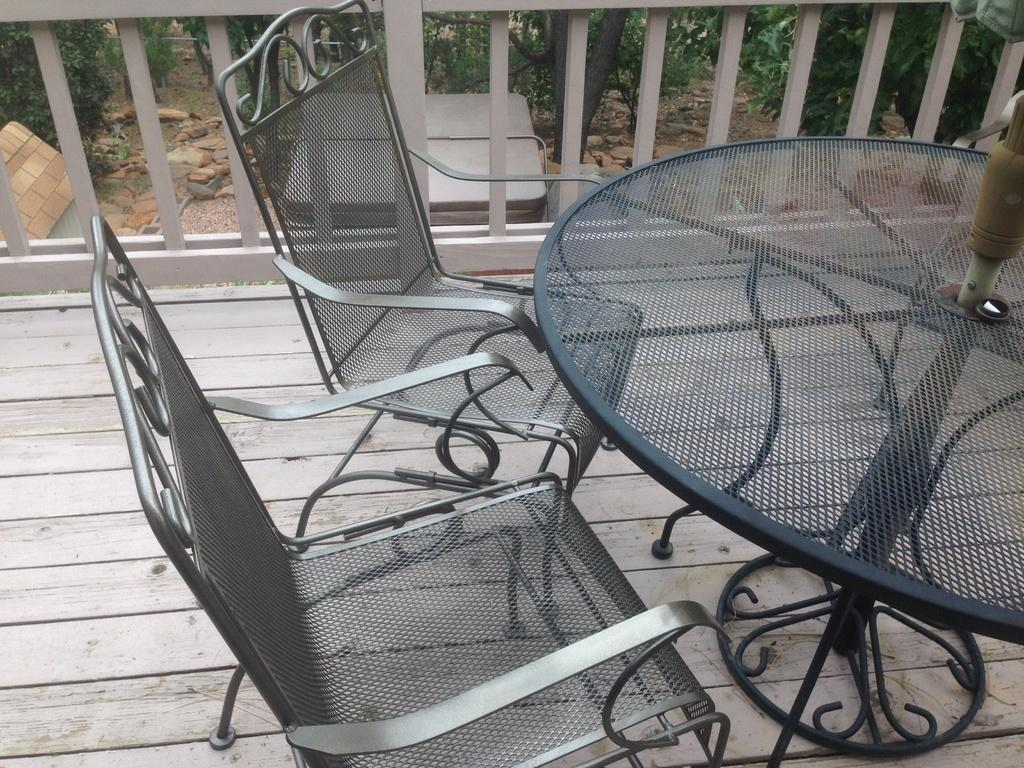What type of chairs are in the image? There are metal chairs in the image. What is located near the chairs? There is a table in the image. What material is the floor made of? The floor is made of wood. What is the purpose of the fence in the image? The fence is present in the image, but its purpose is not explicitly stated. What type of natural elements can be seen in the image? Stones and trees are present in the image. What type of wound can be seen on the stove in the image? There is no stove present in the image, and therefore no wound can be observed. What degree of difficulty is required to climb the trees in the image? The image does not provide information about the difficulty of climbing the trees, nor does it show any people attempting to climb them. 